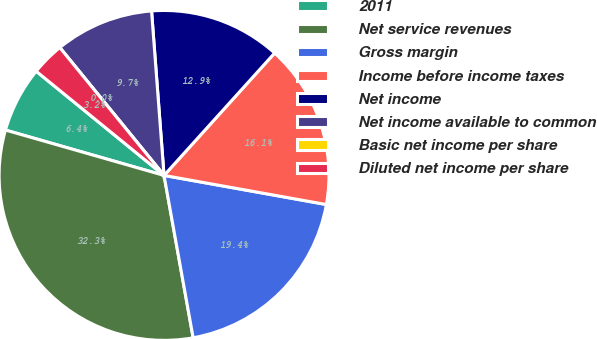<chart> <loc_0><loc_0><loc_500><loc_500><pie_chart><fcel>2011<fcel>Net service revenues<fcel>Gross margin<fcel>Income before income taxes<fcel>Net income<fcel>Net income available to common<fcel>Basic net income per share<fcel>Diluted net income per share<nl><fcel>6.45%<fcel>32.26%<fcel>19.35%<fcel>16.13%<fcel>12.9%<fcel>9.68%<fcel>0.0%<fcel>3.23%<nl></chart> 